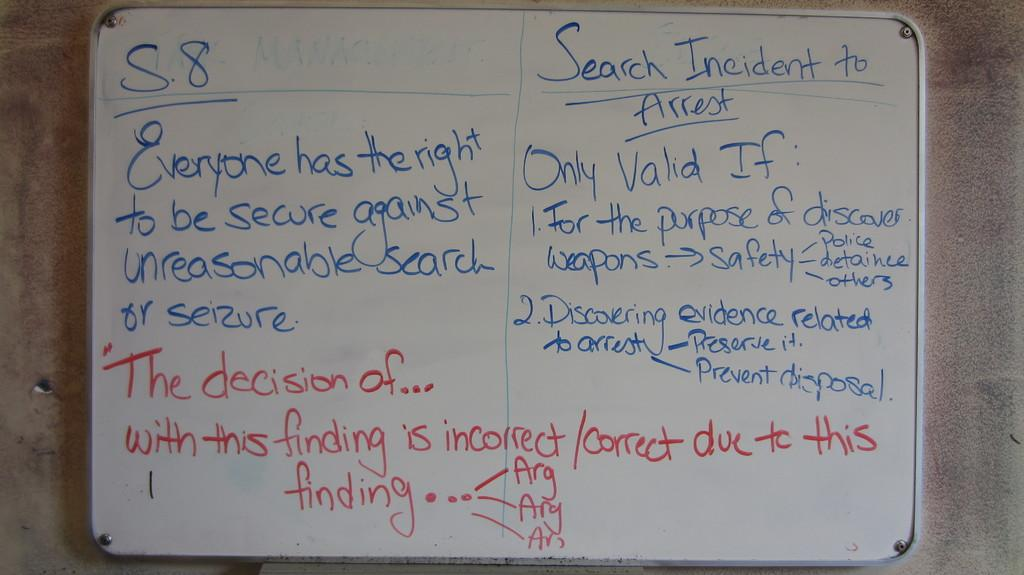<image>
Write a terse but informative summary of the picture. A whiteboard has Search Incident to Arrest written on it. 